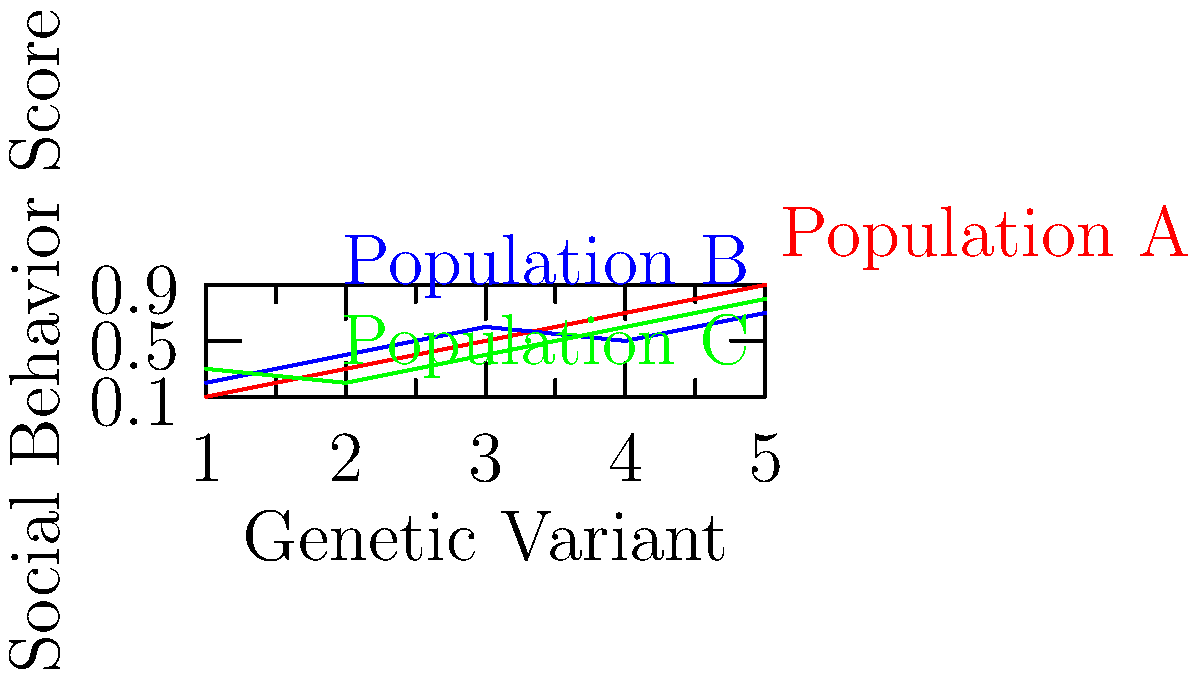Analyze the graph depicting the correlation between genetic variants and social behavior scores across three different populations (A, B, and C). Which population shows the strongest positive correlation between genetic variants and social behavior scores? To determine which population shows the strongest positive correlation between genetic variants and social behavior scores, we need to analyze the slope and consistency of each line:

1. Population A (red line):
   - Shows a clear, consistent upward trend from left to right.
   - The slope is steep and positive throughout the graph.
   - There are no significant fluctuations or dips in the line.

2. Population B (blue line):
   - Shows an overall upward trend, but with some inconsistency.
   - The slope is generally positive but less steep than Population A.
   - There is a slight dip between genetic variants 3 and 4.

3. Population C (green line):
   - Shows an overall upward trend, but with more fluctuations.
   - The slope is positive but less consistent than both A and B.
   - There is a noticeable dip between genetic variants 1 and 2.

A strong positive correlation is characterized by a consistent upward trend with minimal fluctuations. Based on these observations, Population A demonstrates the strongest positive correlation between genetic variants and social behavior scores.
Answer: Population A 